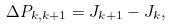<formula> <loc_0><loc_0><loc_500><loc_500>\Delta P _ { k , k + 1 } = J _ { k + 1 } - J _ { k } ,</formula> 